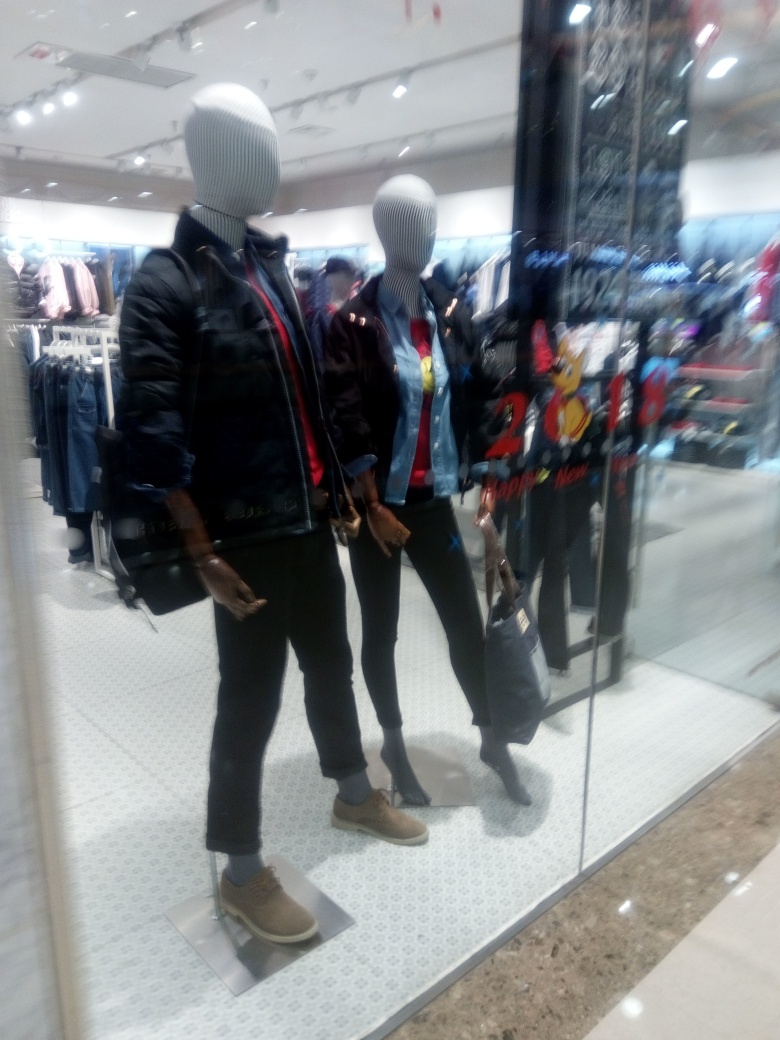What can you tell me about the display setup? The image depicts a retail clothing display with two mannequins positioned on a white platform, likely within a store. The mannequins are positioned to mimic a casual stance that could appeal to shoppers, showcasing the clothing's fit and style in a relatable way. The backdrop includes other garments, suggesting a variety of choices available in the store. 